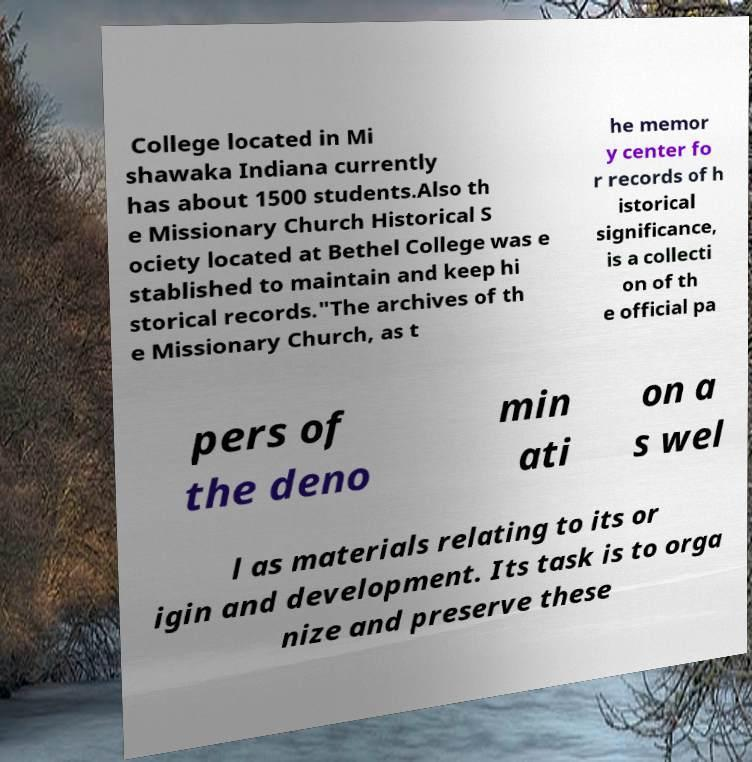There's text embedded in this image that I need extracted. Can you transcribe it verbatim? College located in Mi shawaka Indiana currently has about 1500 students.Also th e Missionary Church Historical S ociety located at Bethel College was e stablished to maintain and keep hi storical records."The archives of th e Missionary Church, as t he memor y center fo r records of h istorical significance, is a collecti on of th e official pa pers of the deno min ati on a s wel l as materials relating to its or igin and development. Its task is to orga nize and preserve these 